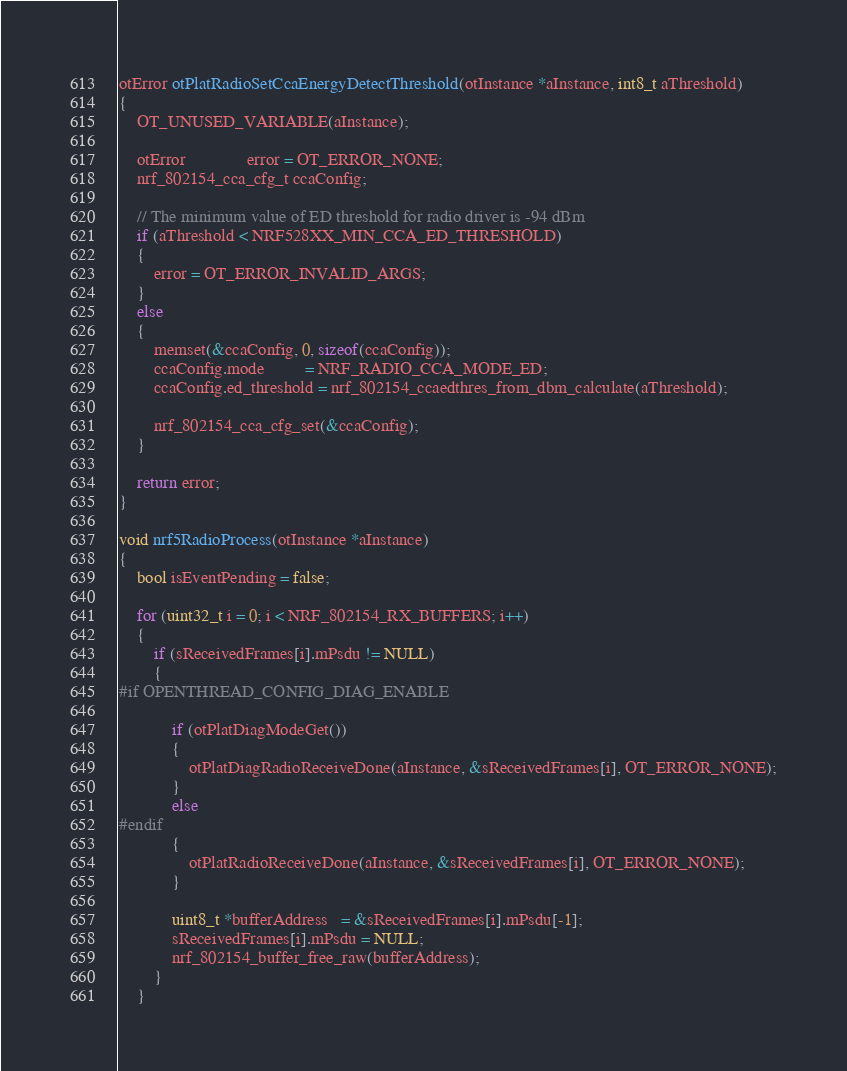<code> <loc_0><loc_0><loc_500><loc_500><_C_>otError otPlatRadioSetCcaEnergyDetectThreshold(otInstance *aInstance, int8_t aThreshold)
{
    OT_UNUSED_VARIABLE(aInstance);

    otError              error = OT_ERROR_NONE;
    nrf_802154_cca_cfg_t ccaConfig;

    // The minimum value of ED threshold for radio driver is -94 dBm
    if (aThreshold < NRF528XX_MIN_CCA_ED_THRESHOLD)
    {
        error = OT_ERROR_INVALID_ARGS;
    }
    else
    {
        memset(&ccaConfig, 0, sizeof(ccaConfig));
        ccaConfig.mode         = NRF_RADIO_CCA_MODE_ED;
        ccaConfig.ed_threshold = nrf_802154_ccaedthres_from_dbm_calculate(aThreshold);

        nrf_802154_cca_cfg_set(&ccaConfig);
    }

    return error;
}

void nrf5RadioProcess(otInstance *aInstance)
{
    bool isEventPending = false;

    for (uint32_t i = 0; i < NRF_802154_RX_BUFFERS; i++)
    {
        if (sReceivedFrames[i].mPsdu != NULL)
        {
#if OPENTHREAD_CONFIG_DIAG_ENABLE

            if (otPlatDiagModeGet())
            {
                otPlatDiagRadioReceiveDone(aInstance, &sReceivedFrames[i], OT_ERROR_NONE);
            }
            else
#endif
            {
                otPlatRadioReceiveDone(aInstance, &sReceivedFrames[i], OT_ERROR_NONE);
            }

            uint8_t *bufferAddress   = &sReceivedFrames[i].mPsdu[-1];
            sReceivedFrames[i].mPsdu = NULL;
            nrf_802154_buffer_free_raw(bufferAddress);
        }
    }
</code> 